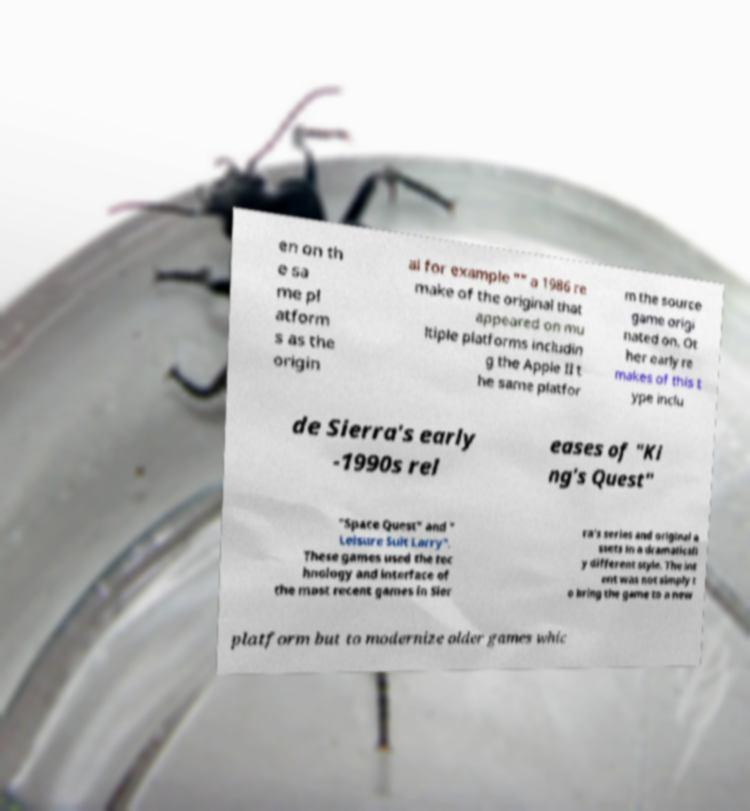Could you extract and type out the text from this image? en on th e sa me pl atform s as the origin al for example "" a 1986 re make of the original that appeared on mu ltiple platforms includin g the Apple II t he same platfor m the source game origi nated on. Ot her early re makes of this t ype inclu de Sierra's early -1990s rel eases of "Ki ng's Quest" "Space Quest" and " Leisure Suit Larry". These games used the tec hnology and interface of the most recent games in Sier ra's series and original a ssets in a dramaticall y different style. The int ent was not simply t o bring the game to a new platform but to modernize older games whic 